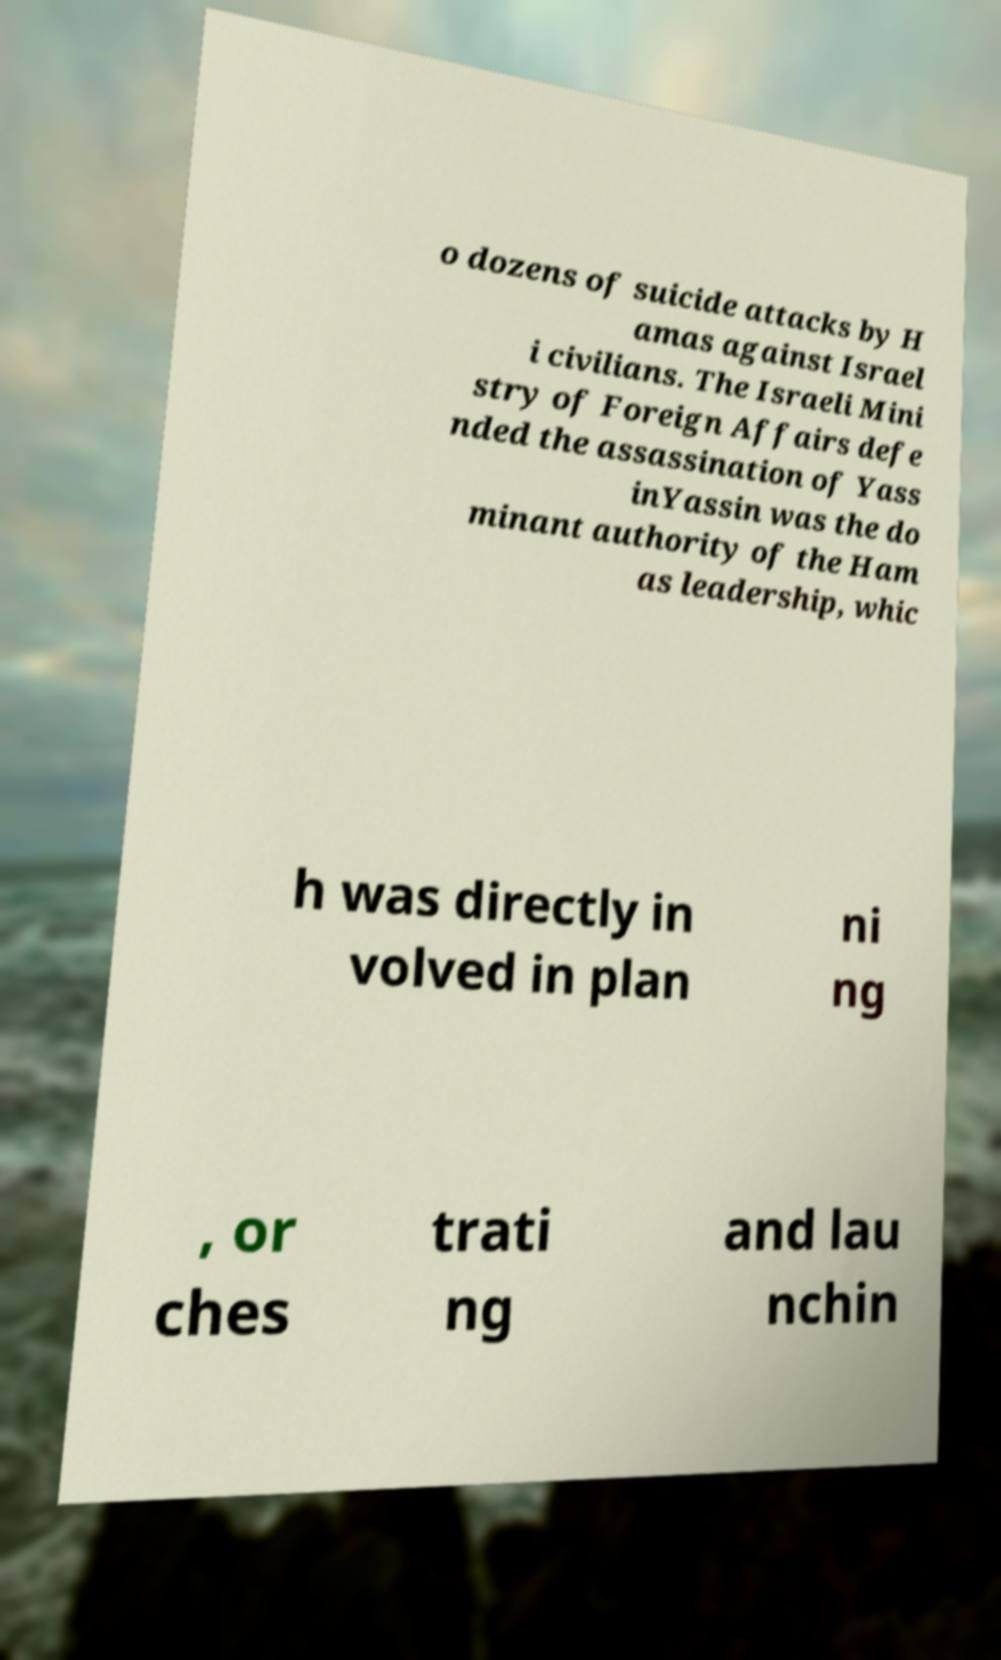There's text embedded in this image that I need extracted. Can you transcribe it verbatim? o dozens of suicide attacks by H amas against Israel i civilians. The Israeli Mini stry of Foreign Affairs defe nded the assassination of Yass inYassin was the do minant authority of the Ham as leadership, whic h was directly in volved in plan ni ng , or ches trati ng and lau nchin 